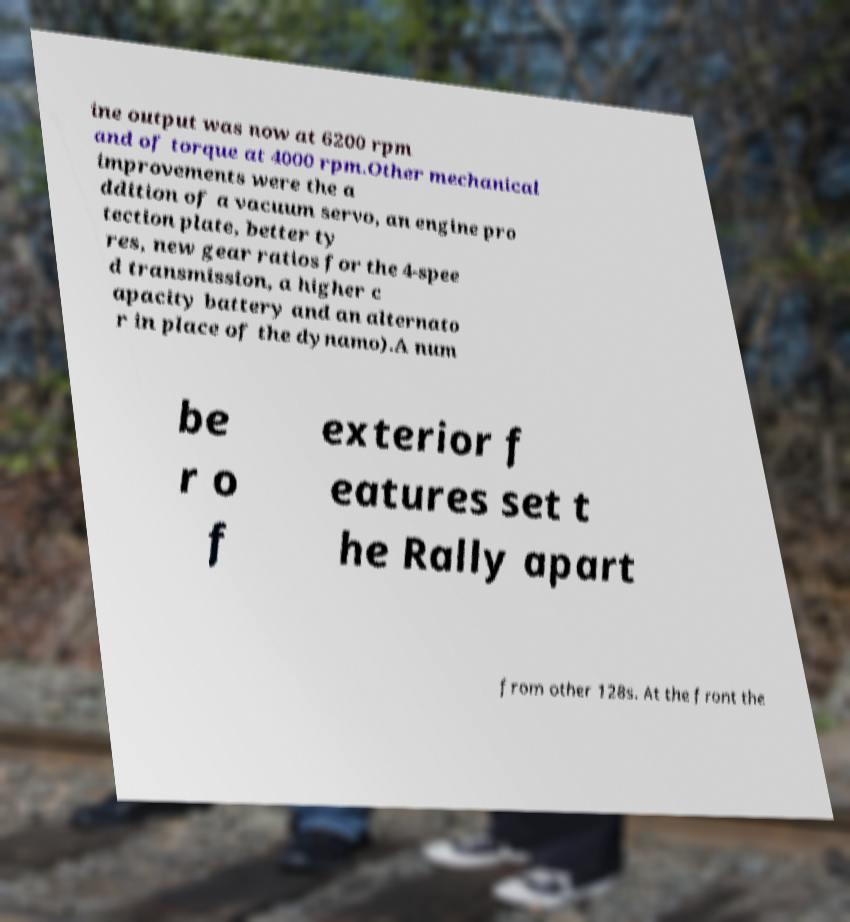Could you extract and type out the text from this image? ine output was now at 6200 rpm and of torque at 4000 rpm.Other mechanical improvements were the a ddition of a vacuum servo, an engine pro tection plate, better ty res, new gear ratios for the 4-spee d transmission, a higher c apacity battery and an alternato r in place of the dynamo).A num be r o f exterior f eatures set t he Rally apart from other 128s. At the front the 